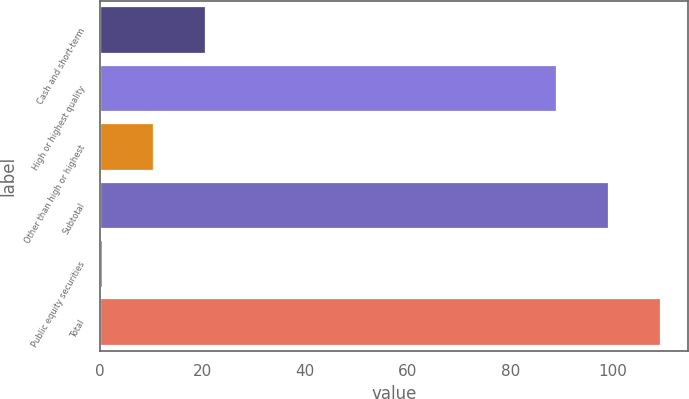Convert chart to OTSL. <chart><loc_0><loc_0><loc_500><loc_500><bar_chart><fcel>Cash and short-term<fcel>High or highest quality<fcel>Other than high or highest<fcel>Subtotal<fcel>Public equity securities<fcel>Total<nl><fcel>20.5<fcel>88.9<fcel>10.4<fcel>99<fcel>0.3<fcel>109.1<nl></chart> 